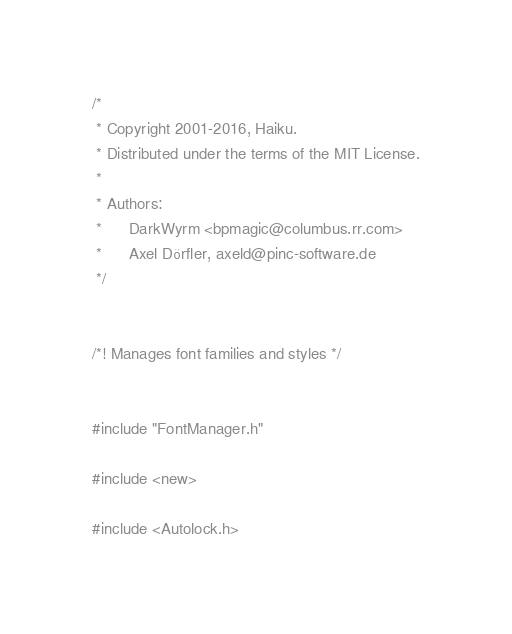<code> <loc_0><loc_0><loc_500><loc_500><_C++_>/*
 * Copyright 2001-2016, Haiku.
 * Distributed under the terms of the MIT License.
 *
 * Authors:
 *		DarkWyrm <bpmagic@columbus.rr.com>
 *		Axel Dörfler, axeld@pinc-software.de
 */


/*!	Manages font families and styles */


#include "FontManager.h"

#include <new>

#include <Autolock.h></code> 